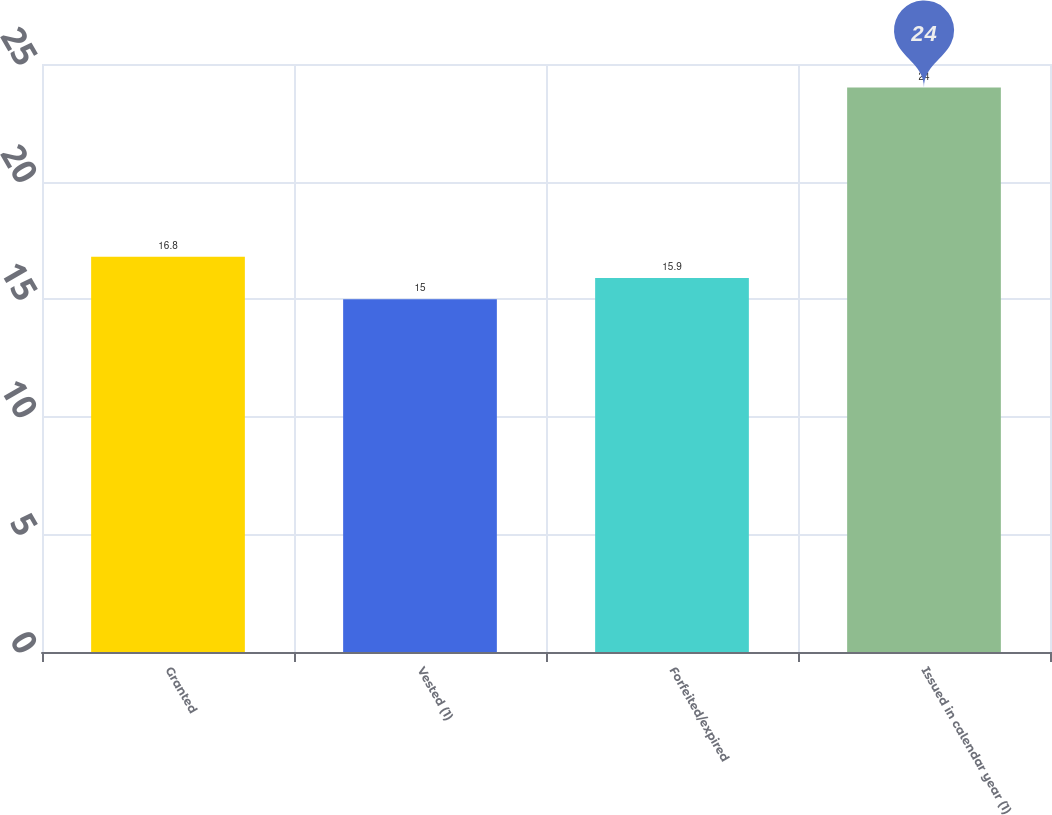<chart> <loc_0><loc_0><loc_500><loc_500><bar_chart><fcel>Granted<fcel>Vested (1)<fcel>Forfeited/expired<fcel>Issued in calendar year (1)<nl><fcel>16.8<fcel>15<fcel>15.9<fcel>24<nl></chart> 